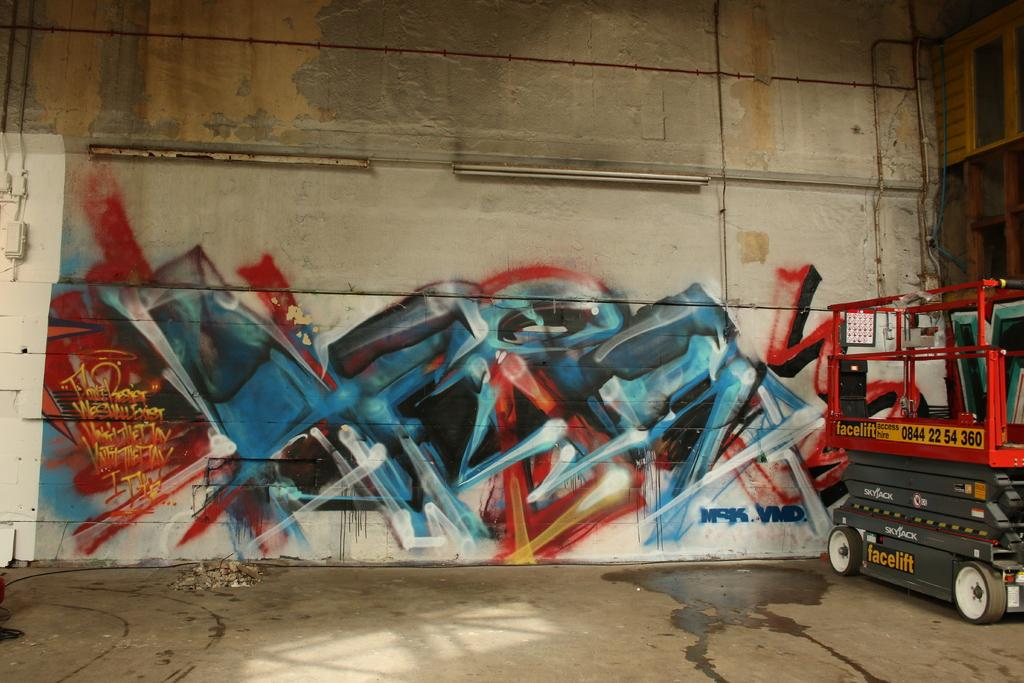What is the main subject in the image? There is a vehicle in the image. Can you describe the colors of the vehicle? The vehicle has red and gray colors. What can be seen in the background of the image? There is a wall in the background of the image. What colors are present on the wall? The wall has cream, blue, and red colors. How many tube lights are visible in the image? There are two tube lights visible in the image. What type of soap is the queen using in the image? There is no queen or soap present in the image. 